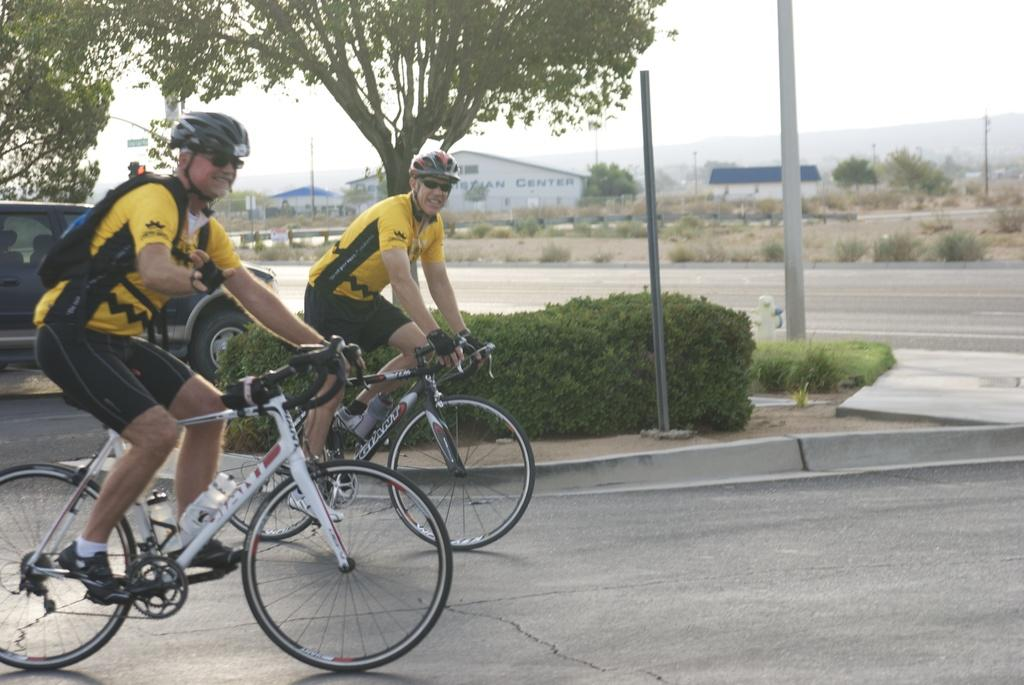How many men are in the image? There are two men in the image. What protective gear are the men wearing? The men are wearing goggles and helmets. What activity are the men engaged in? The men are riding bicycles. Where are the bicycles located? The bicycles are on the road. What type of vegetation can be seen in the image? There are trees in the image. What other structures are present in the image? There are poles and buildings in the image. What can be seen in the background of the image? The sky is visible in the background of the image. How many weeks does it take for the men to grow wings in the image? There are no wings present in the image, and the men do not grow any wings during the depicted activity. 